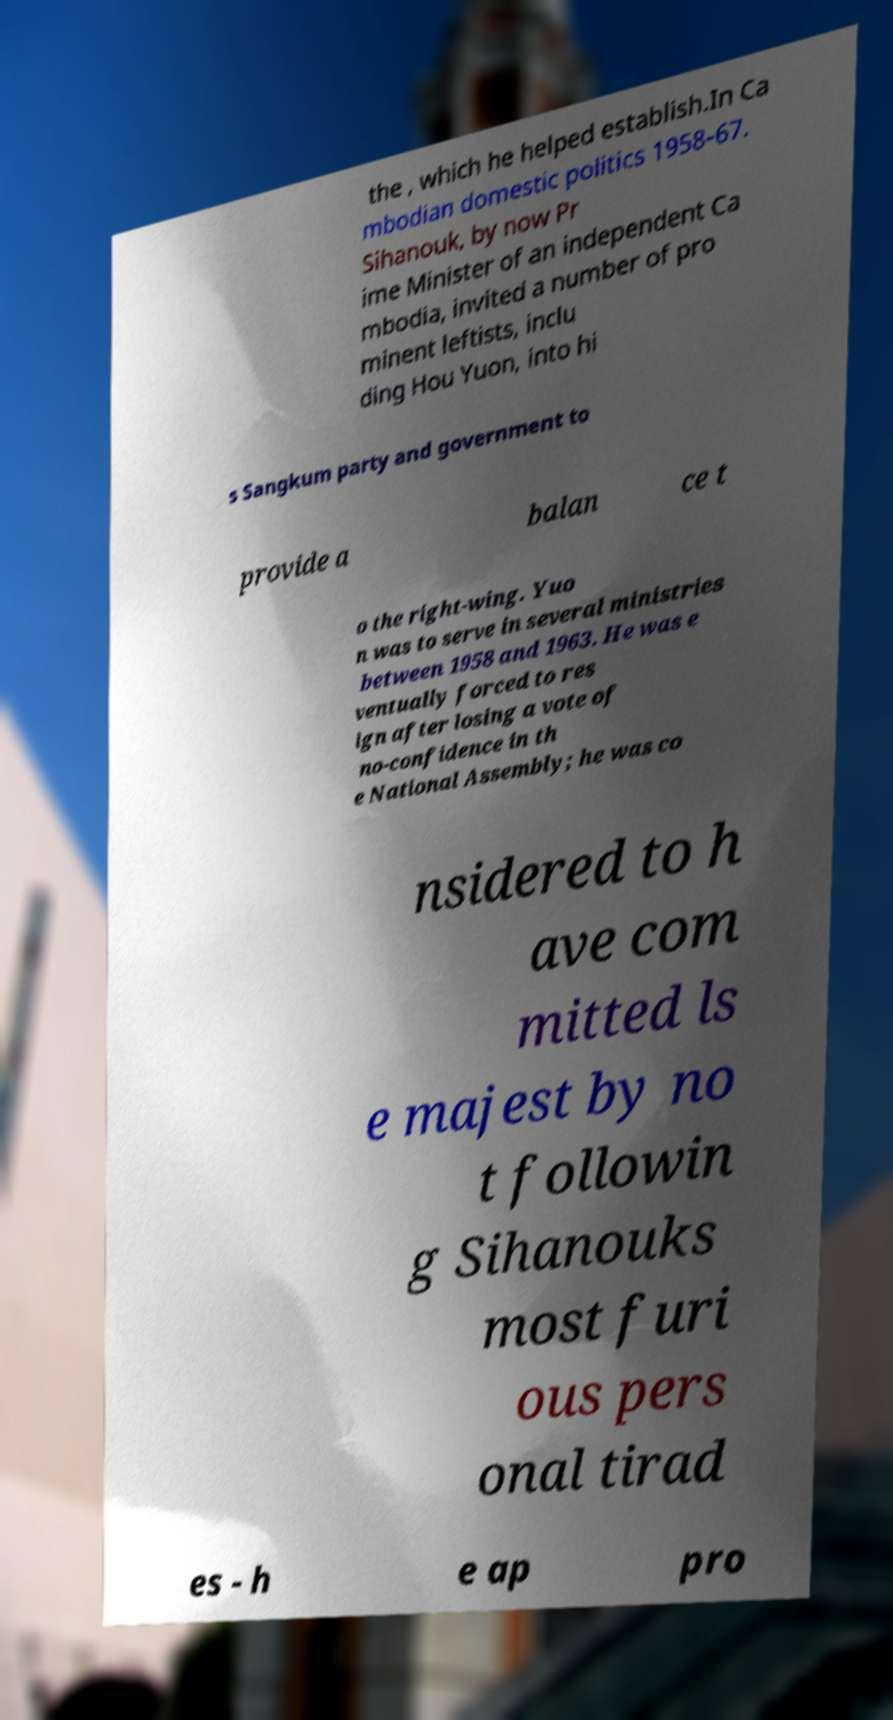There's text embedded in this image that I need extracted. Can you transcribe it verbatim? the , which he helped establish.In Ca mbodian domestic politics 1958-67. Sihanouk, by now Pr ime Minister of an independent Ca mbodia, invited a number of pro minent leftists, inclu ding Hou Yuon, into hi s Sangkum party and government to provide a balan ce t o the right-wing. Yuo n was to serve in several ministries between 1958 and 1963. He was e ventually forced to res ign after losing a vote of no-confidence in th e National Assembly; he was co nsidered to h ave com mitted ls e majest by no t followin g Sihanouks most furi ous pers onal tirad es - h e ap pro 